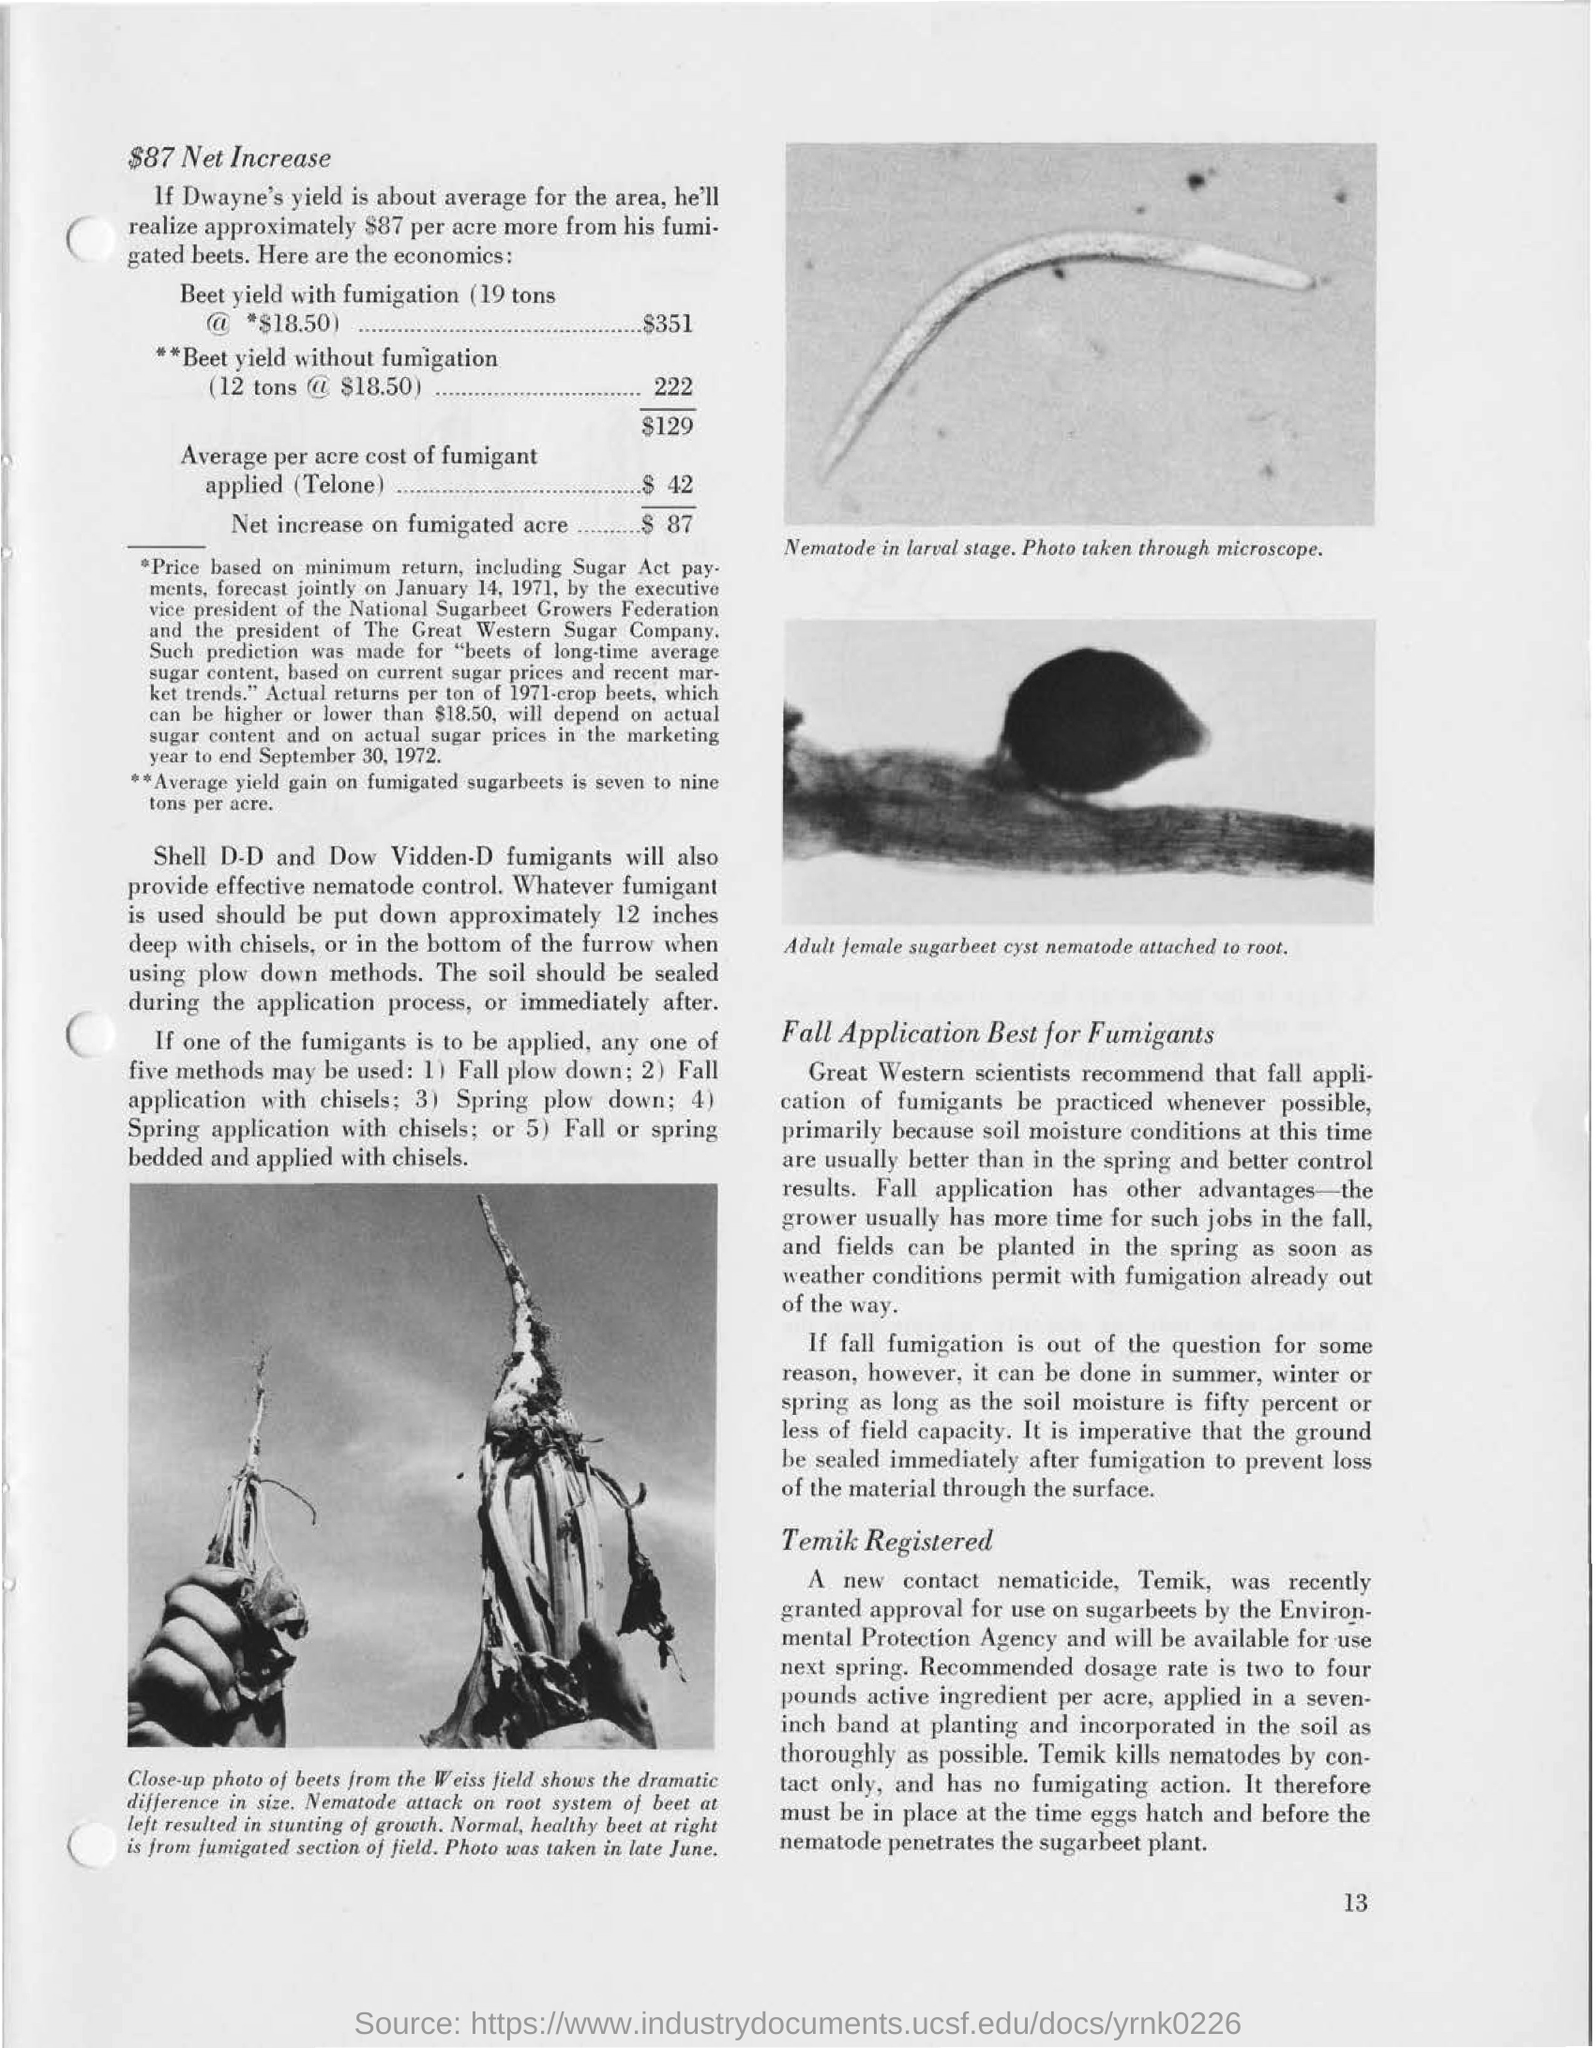Outline some significant characteristics in this image. The average cost of fumigant applied per acre using Telone is $42. The image in the top right depicts a nematode in the larval stage. 